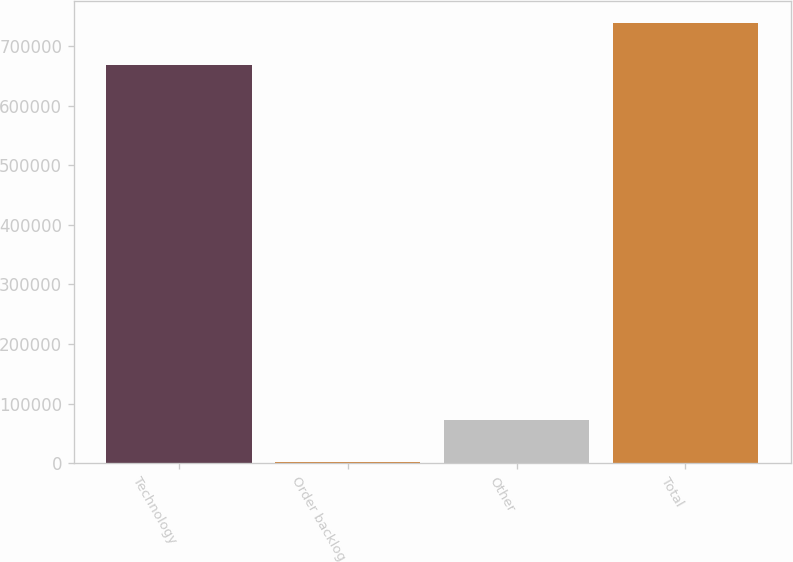<chart> <loc_0><loc_0><loc_500><loc_500><bar_chart><fcel>Technology<fcel>Order backlog<fcel>Other<fcel>Total<nl><fcel>668640<fcel>2000<fcel>72063.3<fcel>738703<nl></chart> 